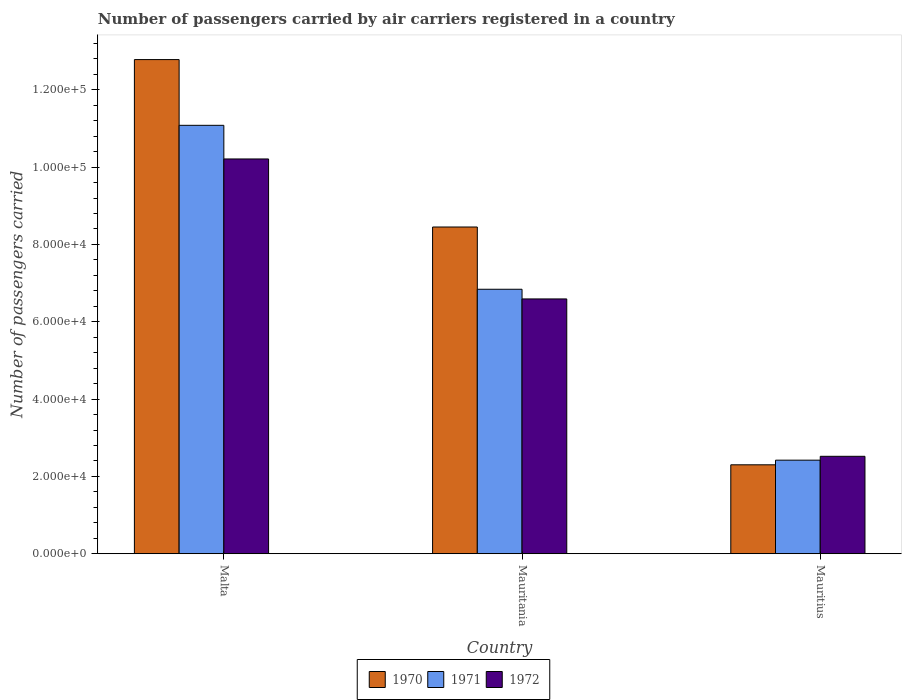How many different coloured bars are there?
Your answer should be compact. 3. How many groups of bars are there?
Ensure brevity in your answer.  3. Are the number of bars on each tick of the X-axis equal?
Provide a short and direct response. Yes. How many bars are there on the 2nd tick from the right?
Offer a very short reply. 3. What is the label of the 2nd group of bars from the left?
Your answer should be very brief. Mauritania. In how many cases, is the number of bars for a given country not equal to the number of legend labels?
Provide a short and direct response. 0. What is the number of passengers carried by air carriers in 1972 in Mauritania?
Your answer should be very brief. 6.59e+04. Across all countries, what is the maximum number of passengers carried by air carriers in 1970?
Offer a terse response. 1.28e+05. Across all countries, what is the minimum number of passengers carried by air carriers in 1971?
Offer a terse response. 2.42e+04. In which country was the number of passengers carried by air carriers in 1971 maximum?
Your answer should be very brief. Malta. In which country was the number of passengers carried by air carriers in 1970 minimum?
Ensure brevity in your answer.  Mauritius. What is the total number of passengers carried by air carriers in 1971 in the graph?
Offer a very short reply. 2.03e+05. What is the difference between the number of passengers carried by air carriers in 1971 in Mauritania and that in Mauritius?
Provide a short and direct response. 4.42e+04. What is the difference between the number of passengers carried by air carriers in 1972 in Malta and the number of passengers carried by air carriers in 1971 in Mauritius?
Your response must be concise. 7.79e+04. What is the average number of passengers carried by air carriers in 1971 per country?
Keep it short and to the point. 6.78e+04. What is the difference between the number of passengers carried by air carriers of/in 1971 and number of passengers carried by air carriers of/in 1970 in Malta?
Make the answer very short. -1.70e+04. In how many countries, is the number of passengers carried by air carriers in 1970 greater than 36000?
Provide a succinct answer. 2. What is the ratio of the number of passengers carried by air carriers in 1970 in Malta to that in Mauritania?
Provide a short and direct response. 1.51. What is the difference between the highest and the second highest number of passengers carried by air carriers in 1972?
Your answer should be compact. -3.62e+04. What is the difference between the highest and the lowest number of passengers carried by air carriers in 1972?
Offer a very short reply. 7.69e+04. In how many countries, is the number of passengers carried by air carriers in 1971 greater than the average number of passengers carried by air carriers in 1971 taken over all countries?
Offer a terse response. 2. What does the 2nd bar from the left in Malta represents?
Offer a terse response. 1971. What does the 2nd bar from the right in Mauritius represents?
Provide a succinct answer. 1971. Are all the bars in the graph horizontal?
Your answer should be very brief. No. What is the difference between two consecutive major ticks on the Y-axis?
Ensure brevity in your answer.  2.00e+04. Does the graph contain any zero values?
Give a very brief answer. No. Does the graph contain grids?
Your response must be concise. No. Where does the legend appear in the graph?
Your answer should be very brief. Bottom center. How are the legend labels stacked?
Ensure brevity in your answer.  Horizontal. What is the title of the graph?
Provide a succinct answer. Number of passengers carried by air carriers registered in a country. What is the label or title of the X-axis?
Make the answer very short. Country. What is the label or title of the Y-axis?
Offer a very short reply. Number of passengers carried. What is the Number of passengers carried of 1970 in Malta?
Your answer should be very brief. 1.28e+05. What is the Number of passengers carried of 1971 in Malta?
Offer a terse response. 1.11e+05. What is the Number of passengers carried of 1972 in Malta?
Offer a very short reply. 1.02e+05. What is the Number of passengers carried in 1970 in Mauritania?
Your answer should be very brief. 8.45e+04. What is the Number of passengers carried in 1971 in Mauritania?
Provide a succinct answer. 6.84e+04. What is the Number of passengers carried of 1972 in Mauritania?
Give a very brief answer. 6.59e+04. What is the Number of passengers carried in 1970 in Mauritius?
Make the answer very short. 2.30e+04. What is the Number of passengers carried of 1971 in Mauritius?
Offer a very short reply. 2.42e+04. What is the Number of passengers carried in 1972 in Mauritius?
Provide a succinct answer. 2.52e+04. Across all countries, what is the maximum Number of passengers carried of 1970?
Your answer should be very brief. 1.28e+05. Across all countries, what is the maximum Number of passengers carried in 1971?
Make the answer very short. 1.11e+05. Across all countries, what is the maximum Number of passengers carried in 1972?
Keep it short and to the point. 1.02e+05. Across all countries, what is the minimum Number of passengers carried of 1970?
Ensure brevity in your answer.  2.30e+04. Across all countries, what is the minimum Number of passengers carried of 1971?
Make the answer very short. 2.42e+04. Across all countries, what is the minimum Number of passengers carried in 1972?
Keep it short and to the point. 2.52e+04. What is the total Number of passengers carried of 1970 in the graph?
Make the answer very short. 2.35e+05. What is the total Number of passengers carried in 1971 in the graph?
Offer a very short reply. 2.03e+05. What is the total Number of passengers carried in 1972 in the graph?
Make the answer very short. 1.93e+05. What is the difference between the Number of passengers carried of 1970 in Malta and that in Mauritania?
Your answer should be compact. 4.33e+04. What is the difference between the Number of passengers carried in 1971 in Malta and that in Mauritania?
Keep it short and to the point. 4.24e+04. What is the difference between the Number of passengers carried of 1972 in Malta and that in Mauritania?
Your answer should be very brief. 3.62e+04. What is the difference between the Number of passengers carried in 1970 in Malta and that in Mauritius?
Your answer should be very brief. 1.05e+05. What is the difference between the Number of passengers carried of 1971 in Malta and that in Mauritius?
Ensure brevity in your answer.  8.66e+04. What is the difference between the Number of passengers carried in 1972 in Malta and that in Mauritius?
Your response must be concise. 7.69e+04. What is the difference between the Number of passengers carried of 1970 in Mauritania and that in Mauritius?
Ensure brevity in your answer.  6.15e+04. What is the difference between the Number of passengers carried of 1971 in Mauritania and that in Mauritius?
Your response must be concise. 4.42e+04. What is the difference between the Number of passengers carried of 1972 in Mauritania and that in Mauritius?
Provide a short and direct response. 4.07e+04. What is the difference between the Number of passengers carried of 1970 in Malta and the Number of passengers carried of 1971 in Mauritania?
Your response must be concise. 5.94e+04. What is the difference between the Number of passengers carried of 1970 in Malta and the Number of passengers carried of 1972 in Mauritania?
Make the answer very short. 6.19e+04. What is the difference between the Number of passengers carried in 1971 in Malta and the Number of passengers carried in 1972 in Mauritania?
Keep it short and to the point. 4.49e+04. What is the difference between the Number of passengers carried in 1970 in Malta and the Number of passengers carried in 1971 in Mauritius?
Make the answer very short. 1.04e+05. What is the difference between the Number of passengers carried in 1970 in Malta and the Number of passengers carried in 1972 in Mauritius?
Make the answer very short. 1.03e+05. What is the difference between the Number of passengers carried in 1971 in Malta and the Number of passengers carried in 1972 in Mauritius?
Provide a short and direct response. 8.56e+04. What is the difference between the Number of passengers carried of 1970 in Mauritania and the Number of passengers carried of 1971 in Mauritius?
Make the answer very short. 6.03e+04. What is the difference between the Number of passengers carried in 1970 in Mauritania and the Number of passengers carried in 1972 in Mauritius?
Make the answer very short. 5.93e+04. What is the difference between the Number of passengers carried in 1971 in Mauritania and the Number of passengers carried in 1972 in Mauritius?
Offer a terse response. 4.32e+04. What is the average Number of passengers carried in 1970 per country?
Keep it short and to the point. 7.84e+04. What is the average Number of passengers carried of 1971 per country?
Offer a terse response. 6.78e+04. What is the average Number of passengers carried in 1972 per country?
Give a very brief answer. 6.44e+04. What is the difference between the Number of passengers carried of 1970 and Number of passengers carried of 1971 in Malta?
Provide a succinct answer. 1.70e+04. What is the difference between the Number of passengers carried in 1970 and Number of passengers carried in 1972 in Malta?
Offer a very short reply. 2.57e+04. What is the difference between the Number of passengers carried of 1971 and Number of passengers carried of 1972 in Malta?
Provide a succinct answer. 8700. What is the difference between the Number of passengers carried in 1970 and Number of passengers carried in 1971 in Mauritania?
Provide a short and direct response. 1.61e+04. What is the difference between the Number of passengers carried of 1970 and Number of passengers carried of 1972 in Mauritania?
Offer a terse response. 1.86e+04. What is the difference between the Number of passengers carried of 1971 and Number of passengers carried of 1972 in Mauritania?
Your response must be concise. 2500. What is the difference between the Number of passengers carried of 1970 and Number of passengers carried of 1971 in Mauritius?
Your response must be concise. -1200. What is the difference between the Number of passengers carried in 1970 and Number of passengers carried in 1972 in Mauritius?
Give a very brief answer. -2200. What is the difference between the Number of passengers carried of 1971 and Number of passengers carried of 1972 in Mauritius?
Make the answer very short. -1000. What is the ratio of the Number of passengers carried of 1970 in Malta to that in Mauritania?
Provide a succinct answer. 1.51. What is the ratio of the Number of passengers carried of 1971 in Malta to that in Mauritania?
Your response must be concise. 1.62. What is the ratio of the Number of passengers carried of 1972 in Malta to that in Mauritania?
Make the answer very short. 1.55. What is the ratio of the Number of passengers carried in 1970 in Malta to that in Mauritius?
Offer a very short reply. 5.56. What is the ratio of the Number of passengers carried of 1971 in Malta to that in Mauritius?
Provide a succinct answer. 4.58. What is the ratio of the Number of passengers carried of 1972 in Malta to that in Mauritius?
Make the answer very short. 4.05. What is the ratio of the Number of passengers carried in 1970 in Mauritania to that in Mauritius?
Ensure brevity in your answer.  3.67. What is the ratio of the Number of passengers carried in 1971 in Mauritania to that in Mauritius?
Provide a short and direct response. 2.83. What is the ratio of the Number of passengers carried in 1972 in Mauritania to that in Mauritius?
Give a very brief answer. 2.62. What is the difference between the highest and the second highest Number of passengers carried of 1970?
Your response must be concise. 4.33e+04. What is the difference between the highest and the second highest Number of passengers carried in 1971?
Your response must be concise. 4.24e+04. What is the difference between the highest and the second highest Number of passengers carried of 1972?
Provide a short and direct response. 3.62e+04. What is the difference between the highest and the lowest Number of passengers carried of 1970?
Keep it short and to the point. 1.05e+05. What is the difference between the highest and the lowest Number of passengers carried in 1971?
Your answer should be very brief. 8.66e+04. What is the difference between the highest and the lowest Number of passengers carried in 1972?
Your response must be concise. 7.69e+04. 